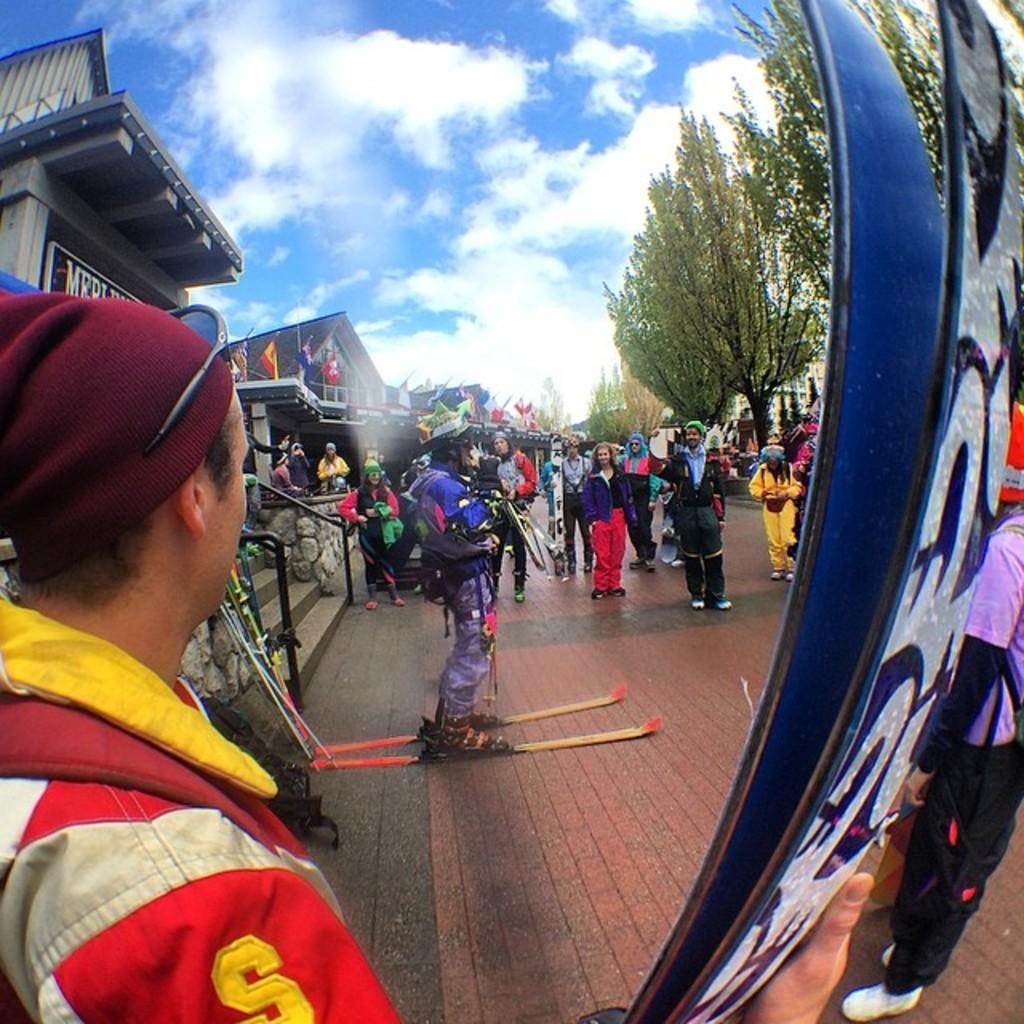<image>
Provide a brief description of the given image. A man wearing a jacket with a yellow S on the sleeve holds skis. 